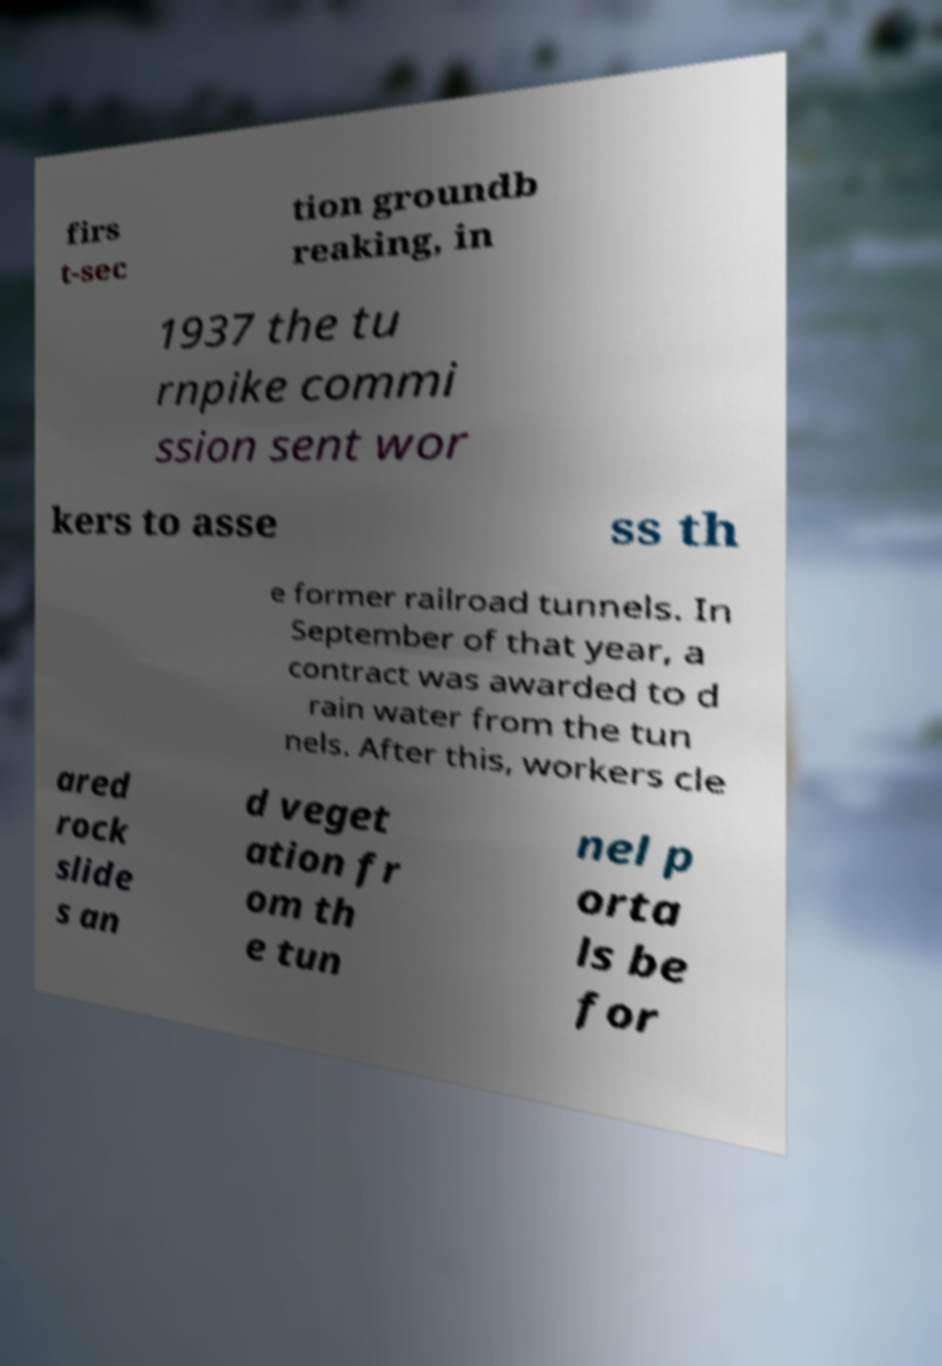I need the written content from this picture converted into text. Can you do that? firs t-sec tion groundb reaking, in 1937 the tu rnpike commi ssion sent wor kers to asse ss th e former railroad tunnels. In September of that year, a contract was awarded to d rain water from the tun nels. After this, workers cle ared rock slide s an d veget ation fr om th e tun nel p orta ls be for 